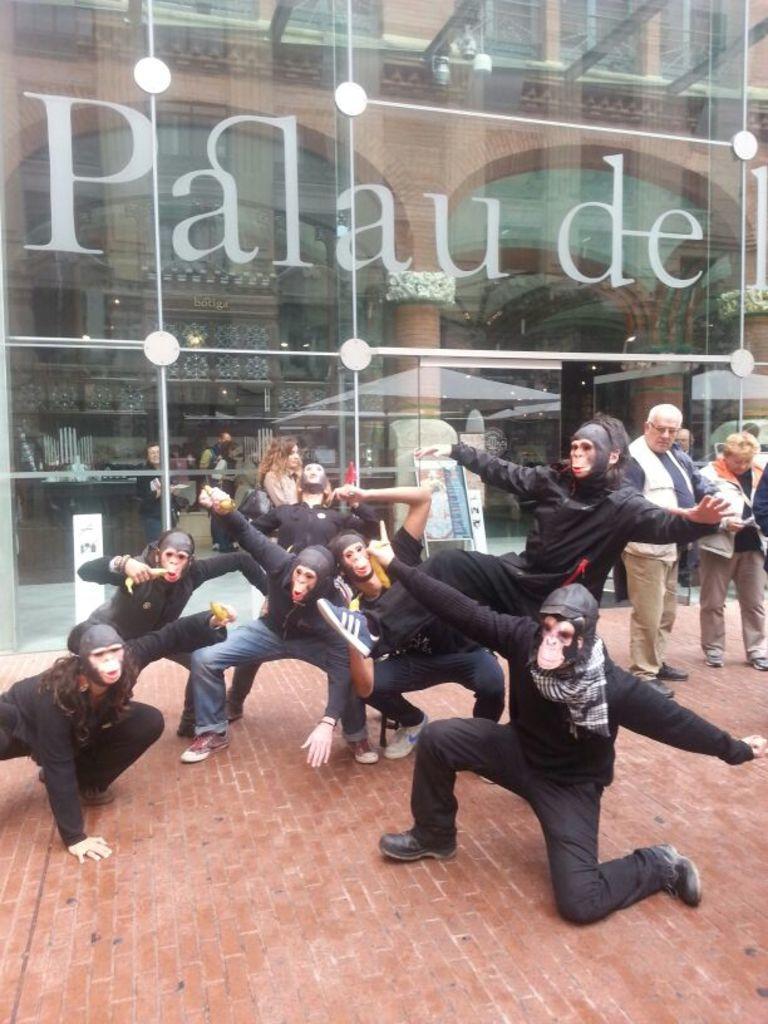Describe this image in one or two sentences. In the center of the image we can see a few people are performing and they are in different costumes. And we can see they are wearing masks. In the background there is a building, glass, pillars, few people are standing and a few other objects. And we can see some text on the wall. 